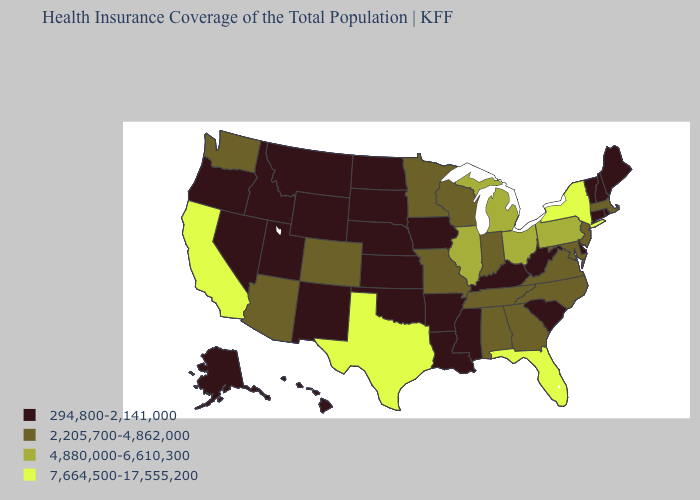What is the value of Alaska?
Concise answer only. 294,800-2,141,000. Name the states that have a value in the range 294,800-2,141,000?
Answer briefly. Alaska, Arkansas, Connecticut, Delaware, Hawaii, Idaho, Iowa, Kansas, Kentucky, Louisiana, Maine, Mississippi, Montana, Nebraska, Nevada, New Hampshire, New Mexico, North Dakota, Oklahoma, Oregon, Rhode Island, South Carolina, South Dakota, Utah, Vermont, West Virginia, Wyoming. What is the highest value in the USA?
Quick response, please. 7,664,500-17,555,200. Which states hav the highest value in the West?
Keep it brief. California. What is the value of California?
Give a very brief answer. 7,664,500-17,555,200. What is the value of North Carolina?
Quick response, please. 2,205,700-4,862,000. Name the states that have a value in the range 4,880,000-6,610,300?
Keep it brief. Illinois, Michigan, Ohio, Pennsylvania. Among the states that border West Virginia , does Ohio have the highest value?
Concise answer only. Yes. Which states have the lowest value in the South?
Give a very brief answer. Arkansas, Delaware, Kentucky, Louisiana, Mississippi, Oklahoma, South Carolina, West Virginia. Among the states that border New York , which have the highest value?
Write a very short answer. Pennsylvania. What is the lowest value in the MidWest?
Answer briefly. 294,800-2,141,000. What is the lowest value in the West?
Concise answer only. 294,800-2,141,000. Name the states that have a value in the range 294,800-2,141,000?
Answer briefly. Alaska, Arkansas, Connecticut, Delaware, Hawaii, Idaho, Iowa, Kansas, Kentucky, Louisiana, Maine, Mississippi, Montana, Nebraska, Nevada, New Hampshire, New Mexico, North Dakota, Oklahoma, Oregon, Rhode Island, South Carolina, South Dakota, Utah, Vermont, West Virginia, Wyoming. Does Texas have the highest value in the USA?
Concise answer only. Yes. Does the map have missing data?
Be succinct. No. 